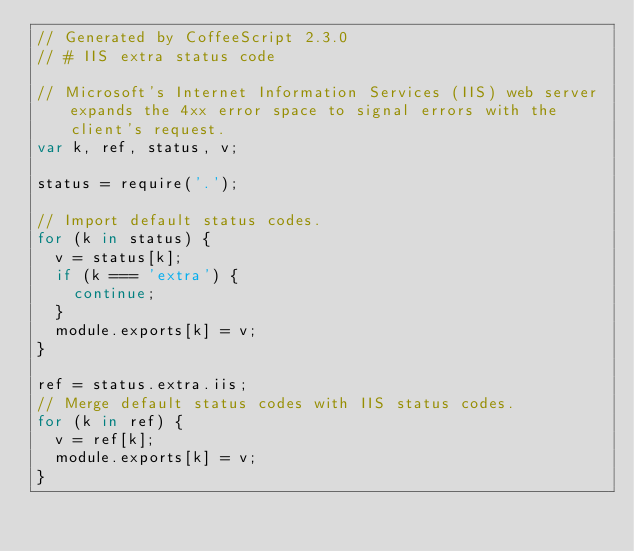<code> <loc_0><loc_0><loc_500><loc_500><_JavaScript_>// Generated by CoffeeScript 2.3.0
// # IIS extra status code

// Microsoft's Internet Information Services (IIS) web server expands the 4xx error space to signal errors with the client's request.
var k, ref, status, v;

status = require('.');

// Import default status codes.
for (k in status) {
  v = status[k];
  if (k === 'extra') {
    continue;
  }
  module.exports[k] = v;
}

ref = status.extra.iis;
// Merge default status codes with IIS status codes.
for (k in ref) {
  v = ref[k];
  module.exports[k] = v;
}
</code> 